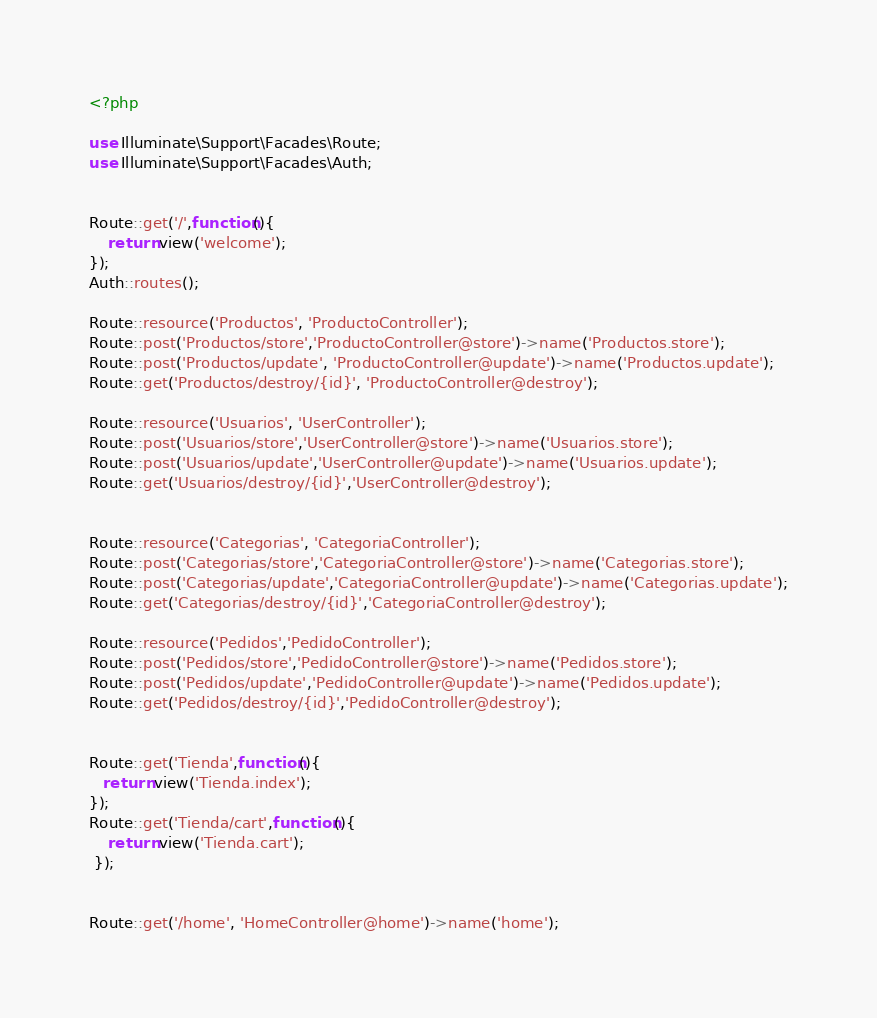Convert code to text. <code><loc_0><loc_0><loc_500><loc_500><_PHP_><?php

use Illuminate\Support\Facades\Route;
use Illuminate\Support\Facades\Auth;


Route::get('/',function(){
    return view('welcome');
});
Auth::routes();

Route::resource('Productos', 'ProductoController');
Route::post('Productos/store','ProductoController@store')->name('Productos.store');
Route::post('Productos/update', 'ProductoController@update')->name('Productos.update');
Route::get('Productos/destroy/{id}', 'ProductoController@destroy');

Route::resource('Usuarios', 'UserController');
Route::post('Usuarios/store','UserController@store')->name('Usuarios.store');
Route::post('Usuarios/update','UserController@update')->name('Usuarios.update');
Route::get('Usuarios/destroy/{id}','UserController@destroy');


Route::resource('Categorias', 'CategoriaController');
Route::post('Categorias/store','CategoriaController@store')->name('Categorias.store');
Route::post('Categorias/update','CategoriaController@update')->name('Categorias.update');
Route::get('Categorias/destroy/{id}','CategoriaController@destroy');

Route::resource('Pedidos','PedidoController');
Route::post('Pedidos/store','PedidoController@store')->name('Pedidos.store');
Route::post('Pedidos/update','PedidoController@update')->name('Pedidos.update');
Route::get('Pedidos/destroy/{id}','PedidoController@destroy');


Route::get('Tienda',function(){
   return view('Tienda.index');
});
Route::get('Tienda/cart',function(){
    return view('Tienda.cart');
 });


Route::get('/home', 'HomeController@home')->name('home');
</code> 